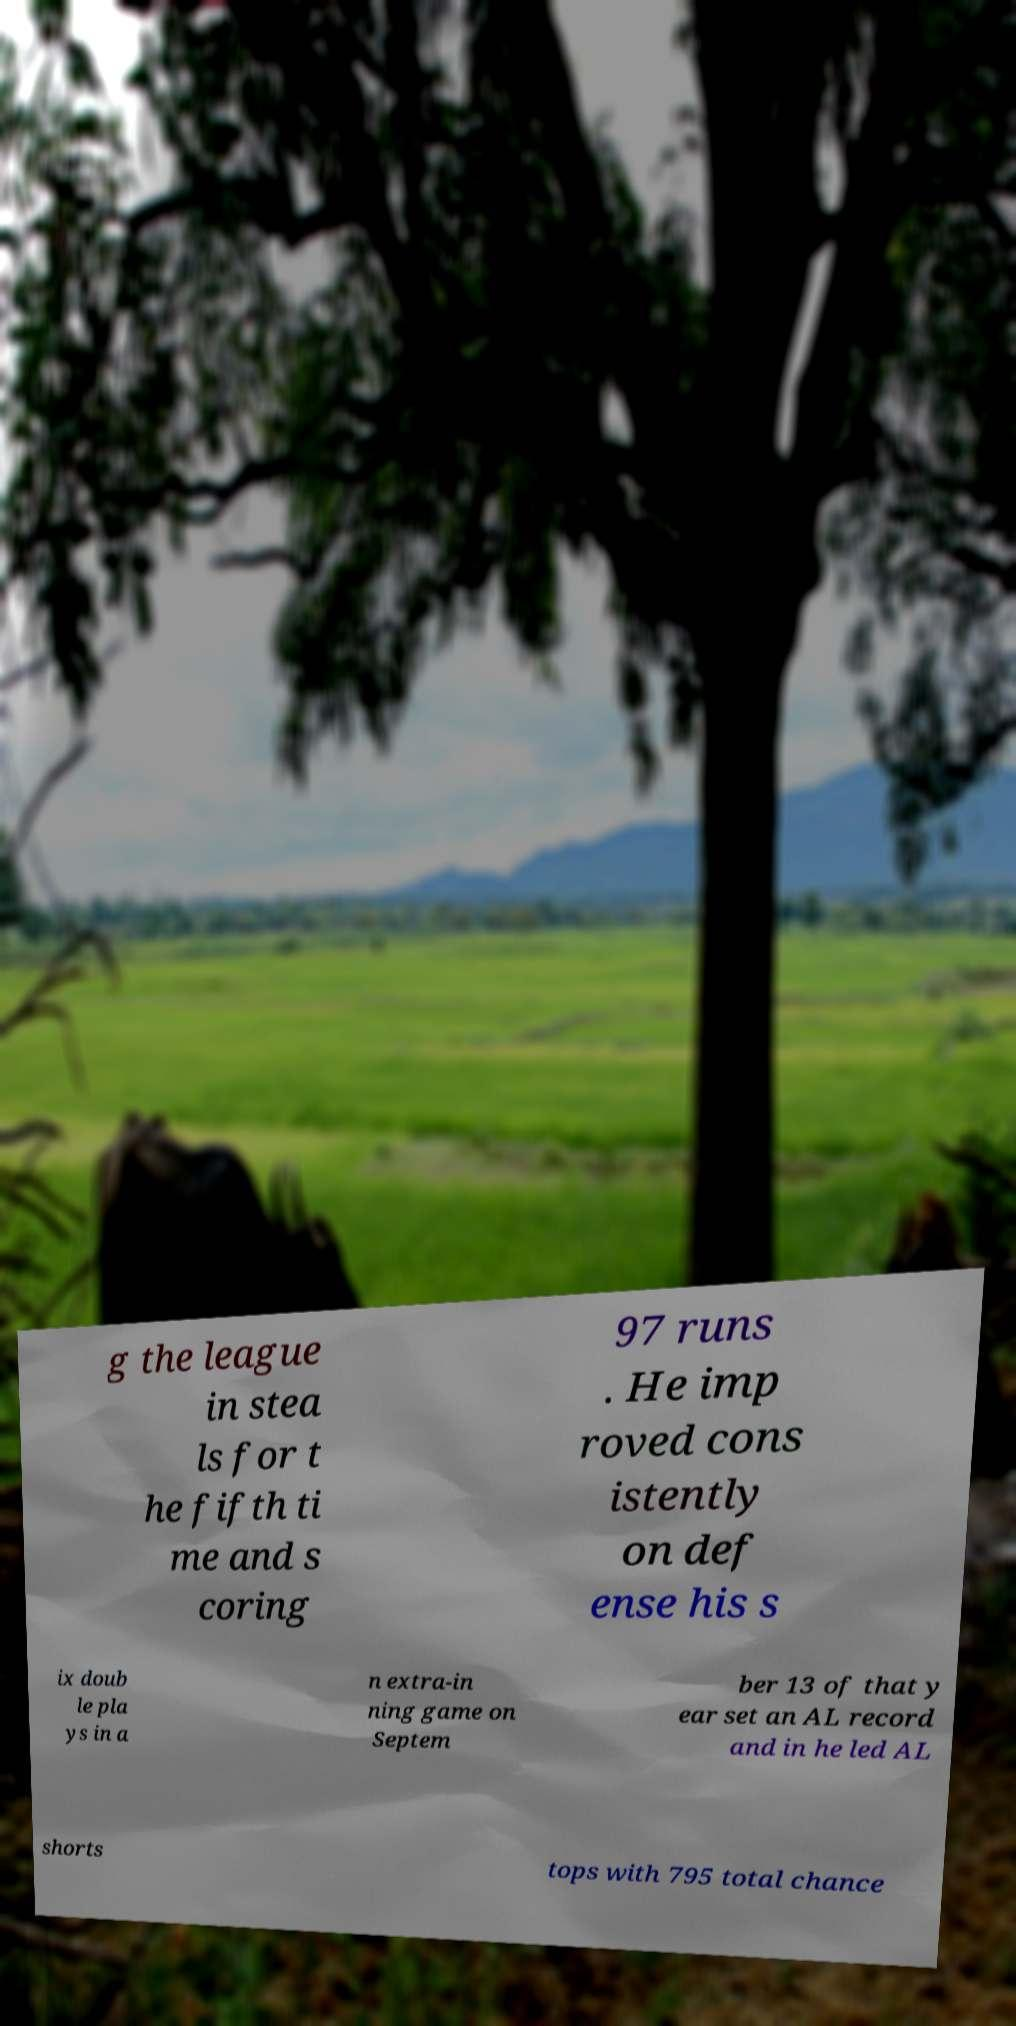There's text embedded in this image that I need extracted. Can you transcribe it verbatim? g the league in stea ls for t he fifth ti me and s coring 97 runs . He imp roved cons istently on def ense his s ix doub le pla ys in a n extra-in ning game on Septem ber 13 of that y ear set an AL record and in he led AL shorts tops with 795 total chance 